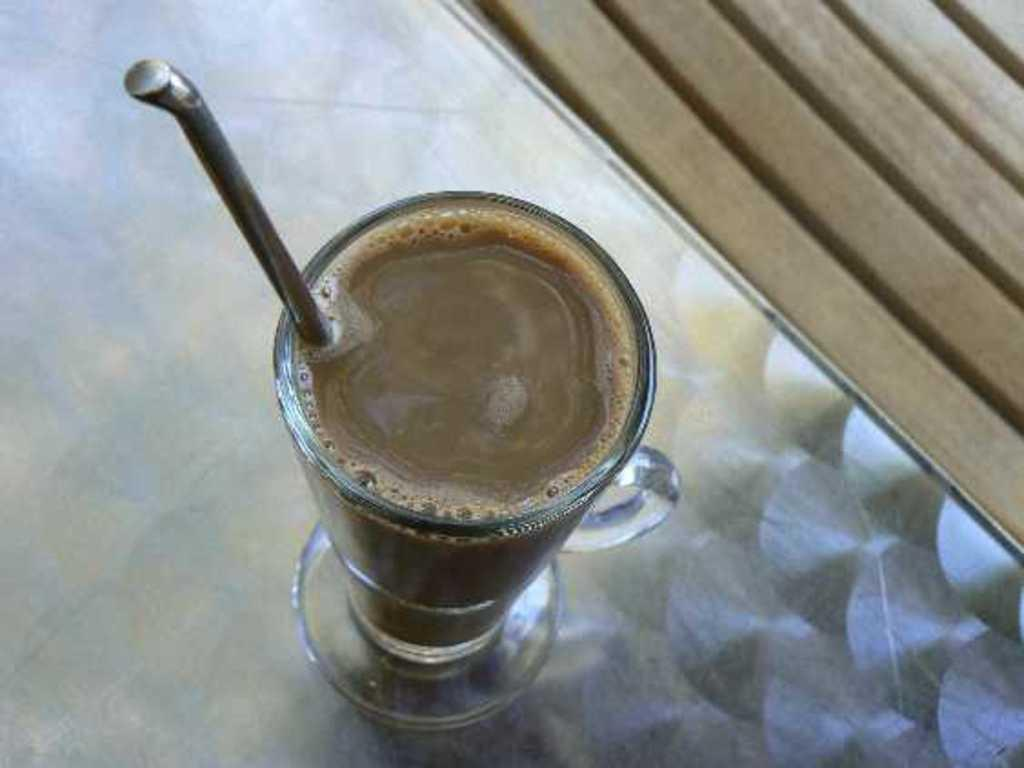What is located at the bottom of the image? There is a table at the bottom of the image. What is on the table? There is a glass on the table. What is inside the glass? There is a drink in the glass. How might someone consume the drink in the glass? There is a straw in the glass, which can be used for drinking. What type of ticket is required to enter the son's room in the image? There is no son or room mentioned in the image, and therefore no ticket is required for entry. 